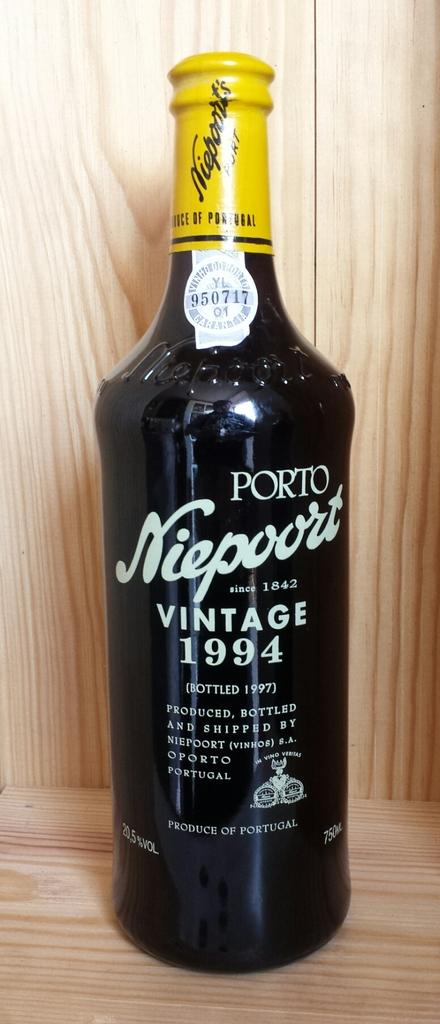<image>
Create a compact narrative representing the image presented. A black bottle of Vintage wine from 1994. 